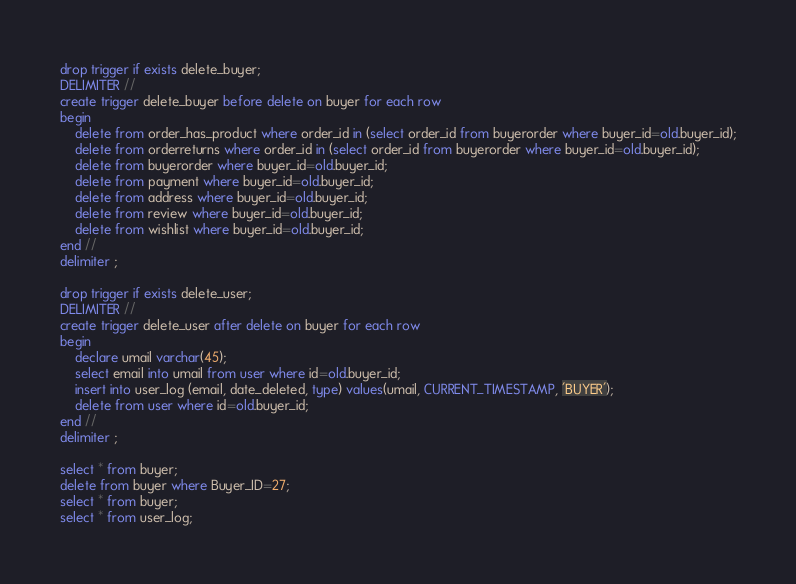<code> <loc_0><loc_0><loc_500><loc_500><_SQL_>drop trigger if exists delete_buyer;
DELIMITER //
create trigger delete_buyer before delete on buyer for each row
begin
	delete from order_has_product where order_id in (select order_id from buyerorder where buyer_id=old.buyer_id);
    delete from orderreturns where order_id in (select order_id from buyerorder where buyer_id=old.buyer_id);
    delete from buyerorder where buyer_id=old.buyer_id;
    delete from payment where buyer_id=old.buyer_id;
    delete from address where buyer_id=old.buyer_id;
    delete from review where buyer_id=old.buyer_id;
    delete from wishlist where buyer_id=old.buyer_id;
end //
delimiter ;

drop trigger if exists delete_user;
DELIMITER //
create trigger delete_user after delete on buyer for each row
begin
	declare umail varchar(45);
    select email into umail from user where id=old.buyer_id;
    insert into user_log (email, date_deleted, type) values(umail, CURRENT_TIMESTAMP, 'BUYER');
    delete from user where id=old.buyer_id;
end //
delimiter ;

select * from buyer;
delete from buyer where Buyer_ID=27;
select * from buyer;
select * from user_log;</code> 